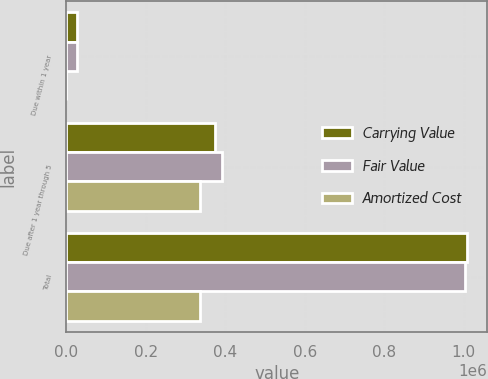Convert chart. <chart><loc_0><loc_0><loc_500><loc_500><stacked_bar_chart><ecel><fcel>Due within 1 year<fcel>Due after 1 year through 5<fcel>Total<nl><fcel>Carrying Value<fcel>27420<fcel>374519<fcel>1.00966e+06<nl><fcel>Fair Value<fcel>27905<fcel>393114<fcel>1.00433e+06<nl><fcel>Amortized Cost<fcel>19<fcel>337778<fcel>337797<nl></chart> 